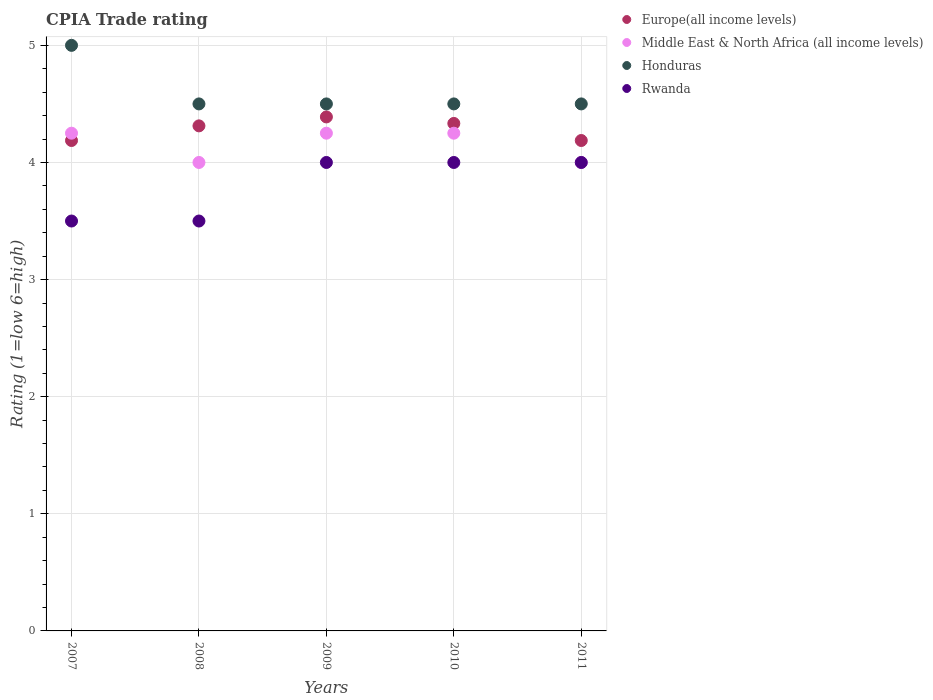How many different coloured dotlines are there?
Provide a short and direct response. 4. Is the number of dotlines equal to the number of legend labels?
Keep it short and to the point. Yes. Across all years, what is the maximum CPIA rating in Europe(all income levels)?
Offer a terse response. 4.39. Across all years, what is the minimum CPIA rating in Europe(all income levels)?
Offer a very short reply. 4.19. What is the total CPIA rating in Europe(all income levels) in the graph?
Ensure brevity in your answer.  21.41. What is the difference between the CPIA rating in Europe(all income levels) in 2007 and that in 2011?
Ensure brevity in your answer.  0. What is the difference between the CPIA rating in Middle East & North Africa (all income levels) in 2011 and the CPIA rating in Europe(all income levels) in 2008?
Keep it short and to the point. -0.31. What is the average CPIA rating in Rwanda per year?
Ensure brevity in your answer.  3.8. In the year 2010, what is the difference between the CPIA rating in Honduras and CPIA rating in Europe(all income levels)?
Provide a short and direct response. 0.17. What is the difference between the highest and the lowest CPIA rating in Europe(all income levels)?
Make the answer very short. 0.2. In how many years, is the CPIA rating in Honduras greater than the average CPIA rating in Honduras taken over all years?
Your answer should be very brief. 1. Is the sum of the CPIA rating in Rwanda in 2007 and 2011 greater than the maximum CPIA rating in Honduras across all years?
Keep it short and to the point. Yes. Does the CPIA rating in Rwanda monotonically increase over the years?
Offer a very short reply. No. How many dotlines are there?
Offer a very short reply. 4. How many years are there in the graph?
Make the answer very short. 5. What is the difference between two consecutive major ticks on the Y-axis?
Offer a very short reply. 1. Are the values on the major ticks of Y-axis written in scientific E-notation?
Ensure brevity in your answer.  No. Does the graph contain grids?
Offer a terse response. Yes. Where does the legend appear in the graph?
Provide a short and direct response. Top right. How many legend labels are there?
Make the answer very short. 4. What is the title of the graph?
Provide a succinct answer. CPIA Trade rating. Does "Montenegro" appear as one of the legend labels in the graph?
Give a very brief answer. No. What is the Rating (1=low 6=high) of Europe(all income levels) in 2007?
Make the answer very short. 4.19. What is the Rating (1=low 6=high) in Middle East & North Africa (all income levels) in 2007?
Your answer should be compact. 4.25. What is the Rating (1=low 6=high) of Europe(all income levels) in 2008?
Your answer should be compact. 4.31. What is the Rating (1=low 6=high) of Europe(all income levels) in 2009?
Ensure brevity in your answer.  4.39. What is the Rating (1=low 6=high) of Middle East & North Africa (all income levels) in 2009?
Your answer should be compact. 4.25. What is the Rating (1=low 6=high) in Honduras in 2009?
Keep it short and to the point. 4.5. What is the Rating (1=low 6=high) in Rwanda in 2009?
Provide a short and direct response. 4. What is the Rating (1=low 6=high) in Europe(all income levels) in 2010?
Offer a terse response. 4.33. What is the Rating (1=low 6=high) of Middle East & North Africa (all income levels) in 2010?
Provide a short and direct response. 4.25. What is the Rating (1=low 6=high) in Honduras in 2010?
Make the answer very short. 4.5. What is the Rating (1=low 6=high) of Rwanda in 2010?
Your answer should be very brief. 4. What is the Rating (1=low 6=high) in Europe(all income levels) in 2011?
Give a very brief answer. 4.19. What is the Rating (1=low 6=high) in Middle East & North Africa (all income levels) in 2011?
Provide a succinct answer. 4. What is the Rating (1=low 6=high) of Honduras in 2011?
Keep it short and to the point. 4.5. What is the Rating (1=low 6=high) in Rwanda in 2011?
Offer a terse response. 4. Across all years, what is the maximum Rating (1=low 6=high) in Europe(all income levels)?
Ensure brevity in your answer.  4.39. Across all years, what is the maximum Rating (1=low 6=high) in Middle East & North Africa (all income levels)?
Ensure brevity in your answer.  4.25. Across all years, what is the maximum Rating (1=low 6=high) in Rwanda?
Your answer should be very brief. 4. Across all years, what is the minimum Rating (1=low 6=high) of Europe(all income levels)?
Make the answer very short. 4.19. Across all years, what is the minimum Rating (1=low 6=high) of Honduras?
Provide a short and direct response. 4.5. What is the total Rating (1=low 6=high) in Europe(all income levels) in the graph?
Make the answer very short. 21.41. What is the total Rating (1=low 6=high) of Middle East & North Africa (all income levels) in the graph?
Provide a short and direct response. 20.75. What is the total Rating (1=low 6=high) in Honduras in the graph?
Offer a very short reply. 23. What is the difference between the Rating (1=low 6=high) of Europe(all income levels) in 2007 and that in 2008?
Offer a very short reply. -0.12. What is the difference between the Rating (1=low 6=high) of Middle East & North Africa (all income levels) in 2007 and that in 2008?
Your response must be concise. 0.25. What is the difference between the Rating (1=low 6=high) of Europe(all income levels) in 2007 and that in 2009?
Your answer should be compact. -0.2. What is the difference between the Rating (1=low 6=high) of Middle East & North Africa (all income levels) in 2007 and that in 2009?
Your answer should be compact. 0. What is the difference between the Rating (1=low 6=high) in Europe(all income levels) in 2007 and that in 2010?
Keep it short and to the point. -0.15. What is the difference between the Rating (1=low 6=high) of Middle East & North Africa (all income levels) in 2007 and that in 2010?
Offer a terse response. 0. What is the difference between the Rating (1=low 6=high) of Rwanda in 2007 and that in 2010?
Give a very brief answer. -0.5. What is the difference between the Rating (1=low 6=high) of Europe(all income levels) in 2007 and that in 2011?
Keep it short and to the point. 0. What is the difference between the Rating (1=low 6=high) in Rwanda in 2007 and that in 2011?
Offer a very short reply. -0.5. What is the difference between the Rating (1=low 6=high) of Europe(all income levels) in 2008 and that in 2009?
Keep it short and to the point. -0.08. What is the difference between the Rating (1=low 6=high) of Honduras in 2008 and that in 2009?
Your answer should be compact. 0. What is the difference between the Rating (1=low 6=high) in Europe(all income levels) in 2008 and that in 2010?
Give a very brief answer. -0.02. What is the difference between the Rating (1=low 6=high) of Honduras in 2008 and that in 2010?
Your answer should be compact. 0. What is the difference between the Rating (1=low 6=high) of Europe(all income levels) in 2008 and that in 2011?
Ensure brevity in your answer.  0.12. What is the difference between the Rating (1=low 6=high) in Honduras in 2008 and that in 2011?
Keep it short and to the point. 0. What is the difference between the Rating (1=low 6=high) of Europe(all income levels) in 2009 and that in 2010?
Your answer should be compact. 0.06. What is the difference between the Rating (1=low 6=high) in Rwanda in 2009 and that in 2010?
Offer a terse response. 0. What is the difference between the Rating (1=low 6=high) in Europe(all income levels) in 2009 and that in 2011?
Offer a terse response. 0.2. What is the difference between the Rating (1=low 6=high) in Middle East & North Africa (all income levels) in 2009 and that in 2011?
Ensure brevity in your answer.  0.25. What is the difference between the Rating (1=low 6=high) in Honduras in 2009 and that in 2011?
Give a very brief answer. 0. What is the difference between the Rating (1=low 6=high) in Europe(all income levels) in 2010 and that in 2011?
Offer a terse response. 0.15. What is the difference between the Rating (1=low 6=high) of Middle East & North Africa (all income levels) in 2010 and that in 2011?
Your answer should be compact. 0.25. What is the difference between the Rating (1=low 6=high) of Europe(all income levels) in 2007 and the Rating (1=low 6=high) of Middle East & North Africa (all income levels) in 2008?
Your answer should be very brief. 0.19. What is the difference between the Rating (1=low 6=high) of Europe(all income levels) in 2007 and the Rating (1=low 6=high) of Honduras in 2008?
Make the answer very short. -0.31. What is the difference between the Rating (1=low 6=high) of Europe(all income levels) in 2007 and the Rating (1=low 6=high) of Rwanda in 2008?
Provide a short and direct response. 0.69. What is the difference between the Rating (1=low 6=high) of Honduras in 2007 and the Rating (1=low 6=high) of Rwanda in 2008?
Keep it short and to the point. 1.5. What is the difference between the Rating (1=low 6=high) of Europe(all income levels) in 2007 and the Rating (1=low 6=high) of Middle East & North Africa (all income levels) in 2009?
Provide a short and direct response. -0.06. What is the difference between the Rating (1=low 6=high) in Europe(all income levels) in 2007 and the Rating (1=low 6=high) in Honduras in 2009?
Provide a succinct answer. -0.31. What is the difference between the Rating (1=low 6=high) in Europe(all income levels) in 2007 and the Rating (1=low 6=high) in Rwanda in 2009?
Offer a very short reply. 0.19. What is the difference between the Rating (1=low 6=high) of Middle East & North Africa (all income levels) in 2007 and the Rating (1=low 6=high) of Rwanda in 2009?
Provide a succinct answer. 0.25. What is the difference between the Rating (1=low 6=high) of Honduras in 2007 and the Rating (1=low 6=high) of Rwanda in 2009?
Provide a succinct answer. 1. What is the difference between the Rating (1=low 6=high) in Europe(all income levels) in 2007 and the Rating (1=low 6=high) in Middle East & North Africa (all income levels) in 2010?
Ensure brevity in your answer.  -0.06. What is the difference between the Rating (1=low 6=high) of Europe(all income levels) in 2007 and the Rating (1=low 6=high) of Honduras in 2010?
Offer a very short reply. -0.31. What is the difference between the Rating (1=low 6=high) of Europe(all income levels) in 2007 and the Rating (1=low 6=high) of Rwanda in 2010?
Keep it short and to the point. 0.19. What is the difference between the Rating (1=low 6=high) in Middle East & North Africa (all income levels) in 2007 and the Rating (1=low 6=high) in Honduras in 2010?
Keep it short and to the point. -0.25. What is the difference between the Rating (1=low 6=high) in Middle East & North Africa (all income levels) in 2007 and the Rating (1=low 6=high) in Rwanda in 2010?
Your response must be concise. 0.25. What is the difference between the Rating (1=low 6=high) of Europe(all income levels) in 2007 and the Rating (1=low 6=high) of Middle East & North Africa (all income levels) in 2011?
Provide a succinct answer. 0.19. What is the difference between the Rating (1=low 6=high) in Europe(all income levels) in 2007 and the Rating (1=low 6=high) in Honduras in 2011?
Give a very brief answer. -0.31. What is the difference between the Rating (1=low 6=high) in Europe(all income levels) in 2007 and the Rating (1=low 6=high) in Rwanda in 2011?
Your response must be concise. 0.19. What is the difference between the Rating (1=low 6=high) of Middle East & North Africa (all income levels) in 2007 and the Rating (1=low 6=high) of Honduras in 2011?
Your answer should be very brief. -0.25. What is the difference between the Rating (1=low 6=high) of Middle East & North Africa (all income levels) in 2007 and the Rating (1=low 6=high) of Rwanda in 2011?
Offer a terse response. 0.25. What is the difference between the Rating (1=low 6=high) of Europe(all income levels) in 2008 and the Rating (1=low 6=high) of Middle East & North Africa (all income levels) in 2009?
Your response must be concise. 0.06. What is the difference between the Rating (1=low 6=high) of Europe(all income levels) in 2008 and the Rating (1=low 6=high) of Honduras in 2009?
Offer a very short reply. -0.19. What is the difference between the Rating (1=low 6=high) of Europe(all income levels) in 2008 and the Rating (1=low 6=high) of Rwanda in 2009?
Your answer should be very brief. 0.31. What is the difference between the Rating (1=low 6=high) of Honduras in 2008 and the Rating (1=low 6=high) of Rwanda in 2009?
Offer a very short reply. 0.5. What is the difference between the Rating (1=low 6=high) of Europe(all income levels) in 2008 and the Rating (1=low 6=high) of Middle East & North Africa (all income levels) in 2010?
Your response must be concise. 0.06. What is the difference between the Rating (1=low 6=high) in Europe(all income levels) in 2008 and the Rating (1=low 6=high) in Honduras in 2010?
Ensure brevity in your answer.  -0.19. What is the difference between the Rating (1=low 6=high) in Europe(all income levels) in 2008 and the Rating (1=low 6=high) in Rwanda in 2010?
Your answer should be very brief. 0.31. What is the difference between the Rating (1=low 6=high) in Europe(all income levels) in 2008 and the Rating (1=low 6=high) in Middle East & North Africa (all income levels) in 2011?
Your response must be concise. 0.31. What is the difference between the Rating (1=low 6=high) of Europe(all income levels) in 2008 and the Rating (1=low 6=high) of Honduras in 2011?
Make the answer very short. -0.19. What is the difference between the Rating (1=low 6=high) in Europe(all income levels) in 2008 and the Rating (1=low 6=high) in Rwanda in 2011?
Your answer should be very brief. 0.31. What is the difference between the Rating (1=low 6=high) in Europe(all income levels) in 2009 and the Rating (1=low 6=high) in Middle East & North Africa (all income levels) in 2010?
Your response must be concise. 0.14. What is the difference between the Rating (1=low 6=high) of Europe(all income levels) in 2009 and the Rating (1=low 6=high) of Honduras in 2010?
Offer a very short reply. -0.11. What is the difference between the Rating (1=low 6=high) of Europe(all income levels) in 2009 and the Rating (1=low 6=high) of Rwanda in 2010?
Your answer should be compact. 0.39. What is the difference between the Rating (1=low 6=high) of Middle East & North Africa (all income levels) in 2009 and the Rating (1=low 6=high) of Honduras in 2010?
Your answer should be compact. -0.25. What is the difference between the Rating (1=low 6=high) in Europe(all income levels) in 2009 and the Rating (1=low 6=high) in Middle East & North Africa (all income levels) in 2011?
Your answer should be compact. 0.39. What is the difference between the Rating (1=low 6=high) in Europe(all income levels) in 2009 and the Rating (1=low 6=high) in Honduras in 2011?
Offer a very short reply. -0.11. What is the difference between the Rating (1=low 6=high) in Europe(all income levels) in 2009 and the Rating (1=low 6=high) in Rwanda in 2011?
Offer a very short reply. 0.39. What is the difference between the Rating (1=low 6=high) in Middle East & North Africa (all income levels) in 2009 and the Rating (1=low 6=high) in Rwanda in 2011?
Offer a terse response. 0.25. What is the difference between the Rating (1=low 6=high) of Europe(all income levels) in 2010 and the Rating (1=low 6=high) of Honduras in 2011?
Provide a short and direct response. -0.17. What is the difference between the Rating (1=low 6=high) in Europe(all income levels) in 2010 and the Rating (1=low 6=high) in Rwanda in 2011?
Provide a succinct answer. 0.33. What is the difference between the Rating (1=low 6=high) in Middle East & North Africa (all income levels) in 2010 and the Rating (1=low 6=high) in Honduras in 2011?
Offer a very short reply. -0.25. What is the difference between the Rating (1=low 6=high) of Middle East & North Africa (all income levels) in 2010 and the Rating (1=low 6=high) of Rwanda in 2011?
Make the answer very short. 0.25. What is the average Rating (1=low 6=high) of Europe(all income levels) per year?
Provide a succinct answer. 4.28. What is the average Rating (1=low 6=high) in Middle East & North Africa (all income levels) per year?
Provide a succinct answer. 4.15. What is the average Rating (1=low 6=high) in Rwanda per year?
Your answer should be compact. 3.8. In the year 2007, what is the difference between the Rating (1=low 6=high) in Europe(all income levels) and Rating (1=low 6=high) in Middle East & North Africa (all income levels)?
Make the answer very short. -0.06. In the year 2007, what is the difference between the Rating (1=low 6=high) of Europe(all income levels) and Rating (1=low 6=high) of Honduras?
Keep it short and to the point. -0.81. In the year 2007, what is the difference between the Rating (1=low 6=high) in Europe(all income levels) and Rating (1=low 6=high) in Rwanda?
Give a very brief answer. 0.69. In the year 2007, what is the difference between the Rating (1=low 6=high) in Middle East & North Africa (all income levels) and Rating (1=low 6=high) in Honduras?
Offer a very short reply. -0.75. In the year 2008, what is the difference between the Rating (1=low 6=high) of Europe(all income levels) and Rating (1=low 6=high) of Middle East & North Africa (all income levels)?
Offer a terse response. 0.31. In the year 2008, what is the difference between the Rating (1=low 6=high) of Europe(all income levels) and Rating (1=low 6=high) of Honduras?
Provide a short and direct response. -0.19. In the year 2008, what is the difference between the Rating (1=low 6=high) in Europe(all income levels) and Rating (1=low 6=high) in Rwanda?
Your answer should be very brief. 0.81. In the year 2008, what is the difference between the Rating (1=low 6=high) in Middle East & North Africa (all income levels) and Rating (1=low 6=high) in Honduras?
Provide a succinct answer. -0.5. In the year 2008, what is the difference between the Rating (1=low 6=high) of Middle East & North Africa (all income levels) and Rating (1=low 6=high) of Rwanda?
Ensure brevity in your answer.  0.5. In the year 2008, what is the difference between the Rating (1=low 6=high) in Honduras and Rating (1=low 6=high) in Rwanda?
Offer a terse response. 1. In the year 2009, what is the difference between the Rating (1=low 6=high) in Europe(all income levels) and Rating (1=low 6=high) in Middle East & North Africa (all income levels)?
Your answer should be very brief. 0.14. In the year 2009, what is the difference between the Rating (1=low 6=high) in Europe(all income levels) and Rating (1=low 6=high) in Honduras?
Ensure brevity in your answer.  -0.11. In the year 2009, what is the difference between the Rating (1=low 6=high) in Europe(all income levels) and Rating (1=low 6=high) in Rwanda?
Offer a very short reply. 0.39. In the year 2009, what is the difference between the Rating (1=low 6=high) in Middle East & North Africa (all income levels) and Rating (1=low 6=high) in Honduras?
Keep it short and to the point. -0.25. In the year 2010, what is the difference between the Rating (1=low 6=high) in Europe(all income levels) and Rating (1=low 6=high) in Middle East & North Africa (all income levels)?
Offer a very short reply. 0.08. In the year 2010, what is the difference between the Rating (1=low 6=high) of Europe(all income levels) and Rating (1=low 6=high) of Honduras?
Your answer should be compact. -0.17. In the year 2010, what is the difference between the Rating (1=low 6=high) of Europe(all income levels) and Rating (1=low 6=high) of Rwanda?
Your answer should be very brief. 0.33. In the year 2010, what is the difference between the Rating (1=low 6=high) in Middle East & North Africa (all income levels) and Rating (1=low 6=high) in Rwanda?
Offer a very short reply. 0.25. In the year 2010, what is the difference between the Rating (1=low 6=high) in Honduras and Rating (1=low 6=high) in Rwanda?
Provide a short and direct response. 0.5. In the year 2011, what is the difference between the Rating (1=low 6=high) of Europe(all income levels) and Rating (1=low 6=high) of Middle East & North Africa (all income levels)?
Ensure brevity in your answer.  0.19. In the year 2011, what is the difference between the Rating (1=low 6=high) of Europe(all income levels) and Rating (1=low 6=high) of Honduras?
Make the answer very short. -0.31. In the year 2011, what is the difference between the Rating (1=low 6=high) of Europe(all income levels) and Rating (1=low 6=high) of Rwanda?
Your answer should be very brief. 0.19. In the year 2011, what is the difference between the Rating (1=low 6=high) in Middle East & North Africa (all income levels) and Rating (1=low 6=high) in Honduras?
Provide a succinct answer. -0.5. In the year 2011, what is the difference between the Rating (1=low 6=high) of Middle East & North Africa (all income levels) and Rating (1=low 6=high) of Rwanda?
Your answer should be very brief. 0. In the year 2011, what is the difference between the Rating (1=low 6=high) in Honduras and Rating (1=low 6=high) in Rwanda?
Offer a terse response. 0.5. What is the ratio of the Rating (1=low 6=high) in Europe(all income levels) in 2007 to that in 2008?
Offer a very short reply. 0.97. What is the ratio of the Rating (1=low 6=high) in Middle East & North Africa (all income levels) in 2007 to that in 2008?
Provide a succinct answer. 1.06. What is the ratio of the Rating (1=low 6=high) of Europe(all income levels) in 2007 to that in 2009?
Keep it short and to the point. 0.95. What is the ratio of the Rating (1=low 6=high) of Middle East & North Africa (all income levels) in 2007 to that in 2009?
Provide a succinct answer. 1. What is the ratio of the Rating (1=low 6=high) in Rwanda in 2007 to that in 2009?
Offer a very short reply. 0.88. What is the ratio of the Rating (1=low 6=high) in Europe(all income levels) in 2007 to that in 2010?
Offer a terse response. 0.97. What is the ratio of the Rating (1=low 6=high) in Middle East & North Africa (all income levels) in 2007 to that in 2010?
Your answer should be very brief. 1. What is the ratio of the Rating (1=low 6=high) of Honduras in 2007 to that in 2010?
Provide a succinct answer. 1.11. What is the ratio of the Rating (1=low 6=high) in Rwanda in 2007 to that in 2010?
Keep it short and to the point. 0.88. What is the ratio of the Rating (1=low 6=high) of Europe(all income levels) in 2007 to that in 2011?
Offer a terse response. 1. What is the ratio of the Rating (1=low 6=high) of Europe(all income levels) in 2008 to that in 2009?
Offer a very short reply. 0.98. What is the ratio of the Rating (1=low 6=high) of Middle East & North Africa (all income levels) in 2008 to that in 2009?
Provide a succinct answer. 0.94. What is the ratio of the Rating (1=low 6=high) in Rwanda in 2008 to that in 2009?
Your answer should be compact. 0.88. What is the ratio of the Rating (1=low 6=high) of Middle East & North Africa (all income levels) in 2008 to that in 2010?
Provide a short and direct response. 0.94. What is the ratio of the Rating (1=low 6=high) of Honduras in 2008 to that in 2010?
Offer a very short reply. 1. What is the ratio of the Rating (1=low 6=high) of Europe(all income levels) in 2008 to that in 2011?
Make the answer very short. 1.03. What is the ratio of the Rating (1=low 6=high) of Middle East & North Africa (all income levels) in 2008 to that in 2011?
Offer a terse response. 1. What is the ratio of the Rating (1=low 6=high) in Rwanda in 2008 to that in 2011?
Provide a succinct answer. 0.88. What is the ratio of the Rating (1=low 6=high) in Europe(all income levels) in 2009 to that in 2010?
Offer a very short reply. 1.01. What is the ratio of the Rating (1=low 6=high) of Middle East & North Africa (all income levels) in 2009 to that in 2010?
Your answer should be very brief. 1. What is the ratio of the Rating (1=low 6=high) in Honduras in 2009 to that in 2010?
Offer a terse response. 1. What is the ratio of the Rating (1=low 6=high) in Europe(all income levels) in 2009 to that in 2011?
Provide a succinct answer. 1.05. What is the ratio of the Rating (1=low 6=high) of Middle East & North Africa (all income levels) in 2009 to that in 2011?
Give a very brief answer. 1.06. What is the ratio of the Rating (1=low 6=high) of Honduras in 2009 to that in 2011?
Offer a terse response. 1. What is the ratio of the Rating (1=low 6=high) of Rwanda in 2009 to that in 2011?
Your response must be concise. 1. What is the ratio of the Rating (1=low 6=high) of Europe(all income levels) in 2010 to that in 2011?
Keep it short and to the point. 1.03. What is the ratio of the Rating (1=low 6=high) of Rwanda in 2010 to that in 2011?
Offer a very short reply. 1. What is the difference between the highest and the second highest Rating (1=low 6=high) of Europe(all income levels)?
Your answer should be compact. 0.06. What is the difference between the highest and the second highest Rating (1=low 6=high) of Rwanda?
Offer a very short reply. 0. What is the difference between the highest and the lowest Rating (1=low 6=high) in Europe(all income levels)?
Offer a terse response. 0.2. What is the difference between the highest and the lowest Rating (1=low 6=high) in Middle East & North Africa (all income levels)?
Your response must be concise. 0.25. What is the difference between the highest and the lowest Rating (1=low 6=high) of Honduras?
Your answer should be compact. 0.5. 